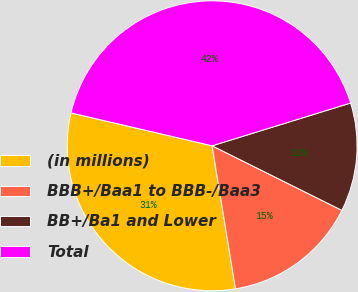<chart> <loc_0><loc_0><loc_500><loc_500><pie_chart><fcel>(in millions)<fcel>BBB+/Baa1 to BBB-/Baa3<fcel>BB+/Ba1 and Lower<fcel>Total<nl><fcel>31.22%<fcel>15.07%<fcel>12.12%<fcel>41.59%<nl></chart> 